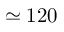Convert formula to latex. <formula><loc_0><loc_0><loc_500><loc_500>\simeq 1 2 0</formula> 